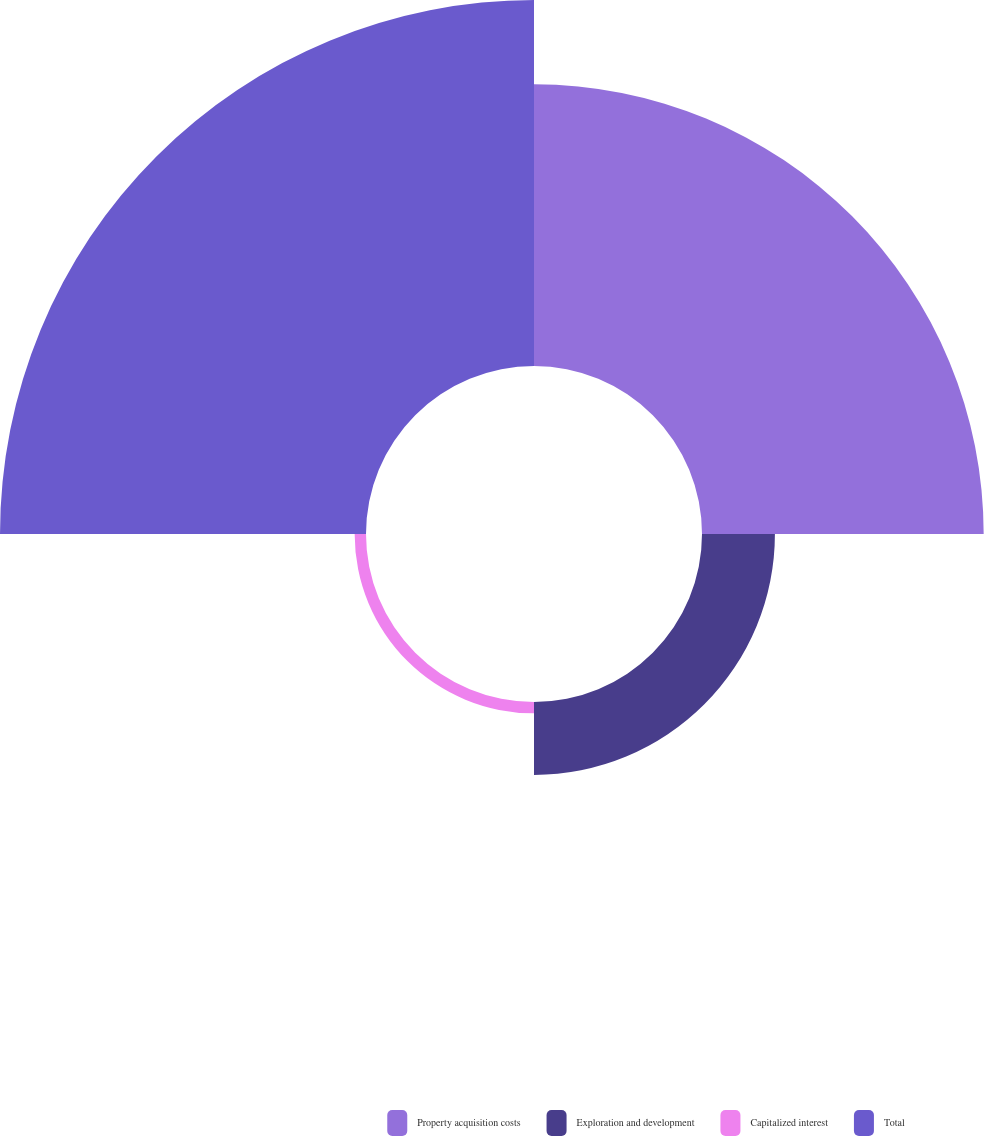Convert chart. <chart><loc_0><loc_0><loc_500><loc_500><pie_chart><fcel>Property acquisition costs<fcel>Exploration and development<fcel>Capitalized interest<fcel>Total<nl><fcel>38.48%<fcel>9.96%<fcel>1.55%<fcel>50.0%<nl></chart> 